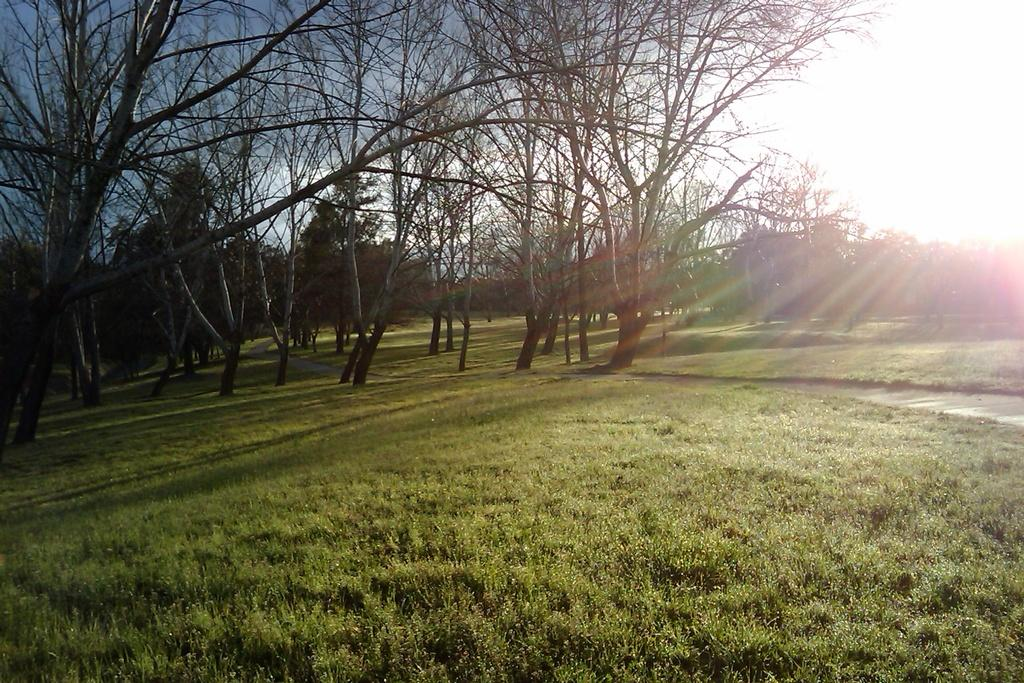What type of vegetation can be seen in the background of the image? There are trees in the background of the image. What else is visible in the background of the image? The sky is visible in the background of the image. What type of ground surface is at the bottom of the image? There is grass at the bottom of the image. What type of glue is being used by the writer in the image? There is no writer or glue present in the image. How does the society depicted in the image function? There is no society depicted in the image; it features trees, sky, and grass. 